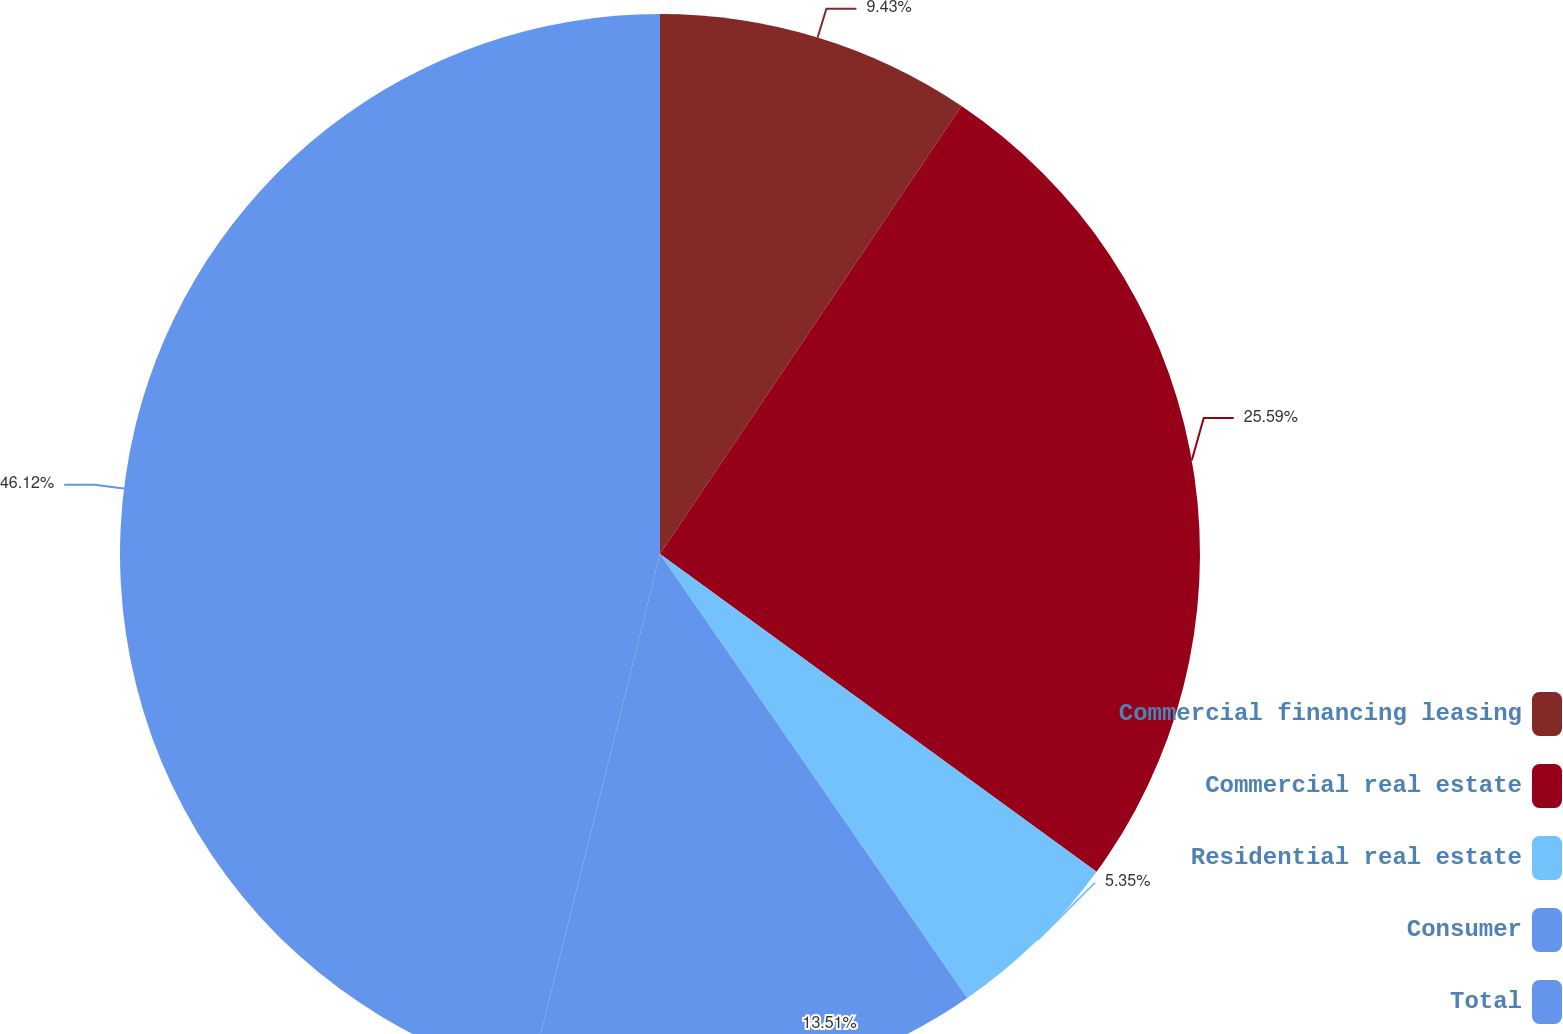Convert chart to OTSL. <chart><loc_0><loc_0><loc_500><loc_500><pie_chart><fcel>Commercial financing leasing<fcel>Commercial real estate<fcel>Residential real estate<fcel>Consumer<fcel>Total<nl><fcel>9.43%<fcel>25.59%<fcel>5.35%<fcel>13.51%<fcel>46.13%<nl></chart> 